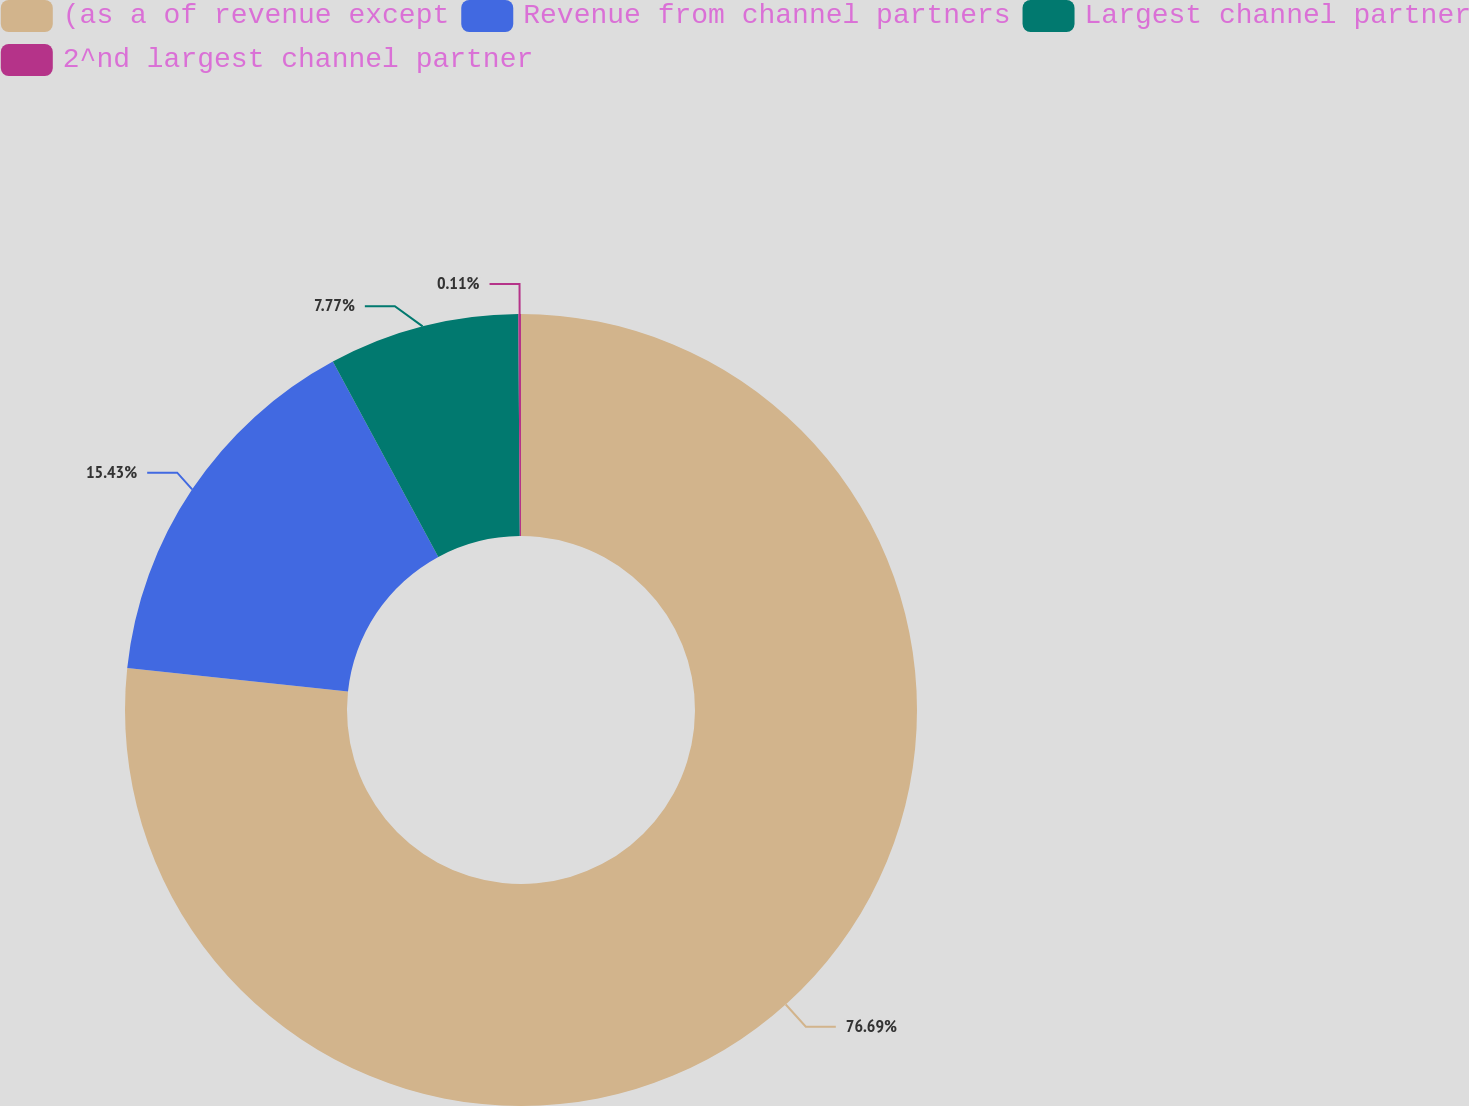<chart> <loc_0><loc_0><loc_500><loc_500><pie_chart><fcel>(as a of revenue except<fcel>Revenue from channel partners<fcel>Largest channel partner<fcel>2^nd largest channel partner<nl><fcel>76.69%<fcel>15.43%<fcel>7.77%<fcel>0.11%<nl></chart> 